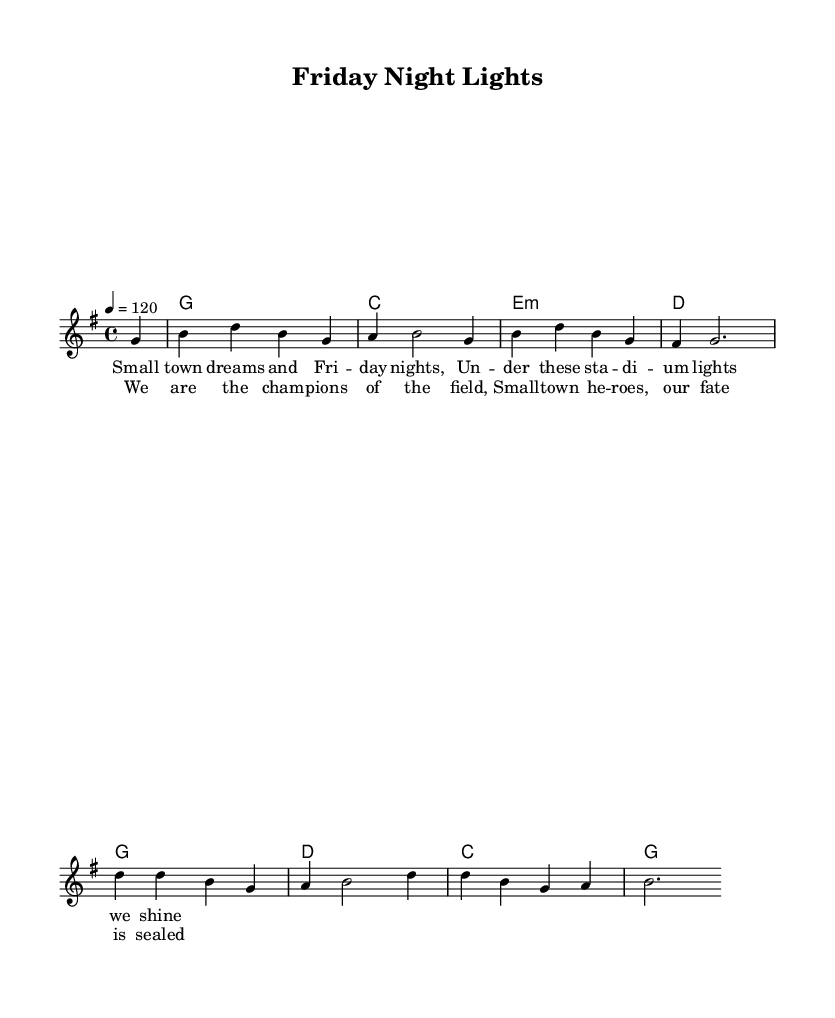What is the key signature of this music? The key signature is G major, which has one sharp (F#). This can be determined by looking at the key signature indicated at the beginning of the sheet music.
Answer: G major What is the time signature of this piece? The time signature is 4/4, which indicates that there are four beats in a measure and the quarter note gets one beat. This is shown at the start of the sheet music.
Answer: 4/4 What is the tempo marking in the score? The tempo marking is 120 beats per minute, which is indicated at the beginning of the score with the annotation "4 = 120".
Answer: 120 How many measures are in the melody? There are 8 measures in the melody section, which can be counted by observing the bar lines separating the musical segments in the melody.
Answer: 8 What is the theme of the lyrics in the verse? The theme of the lyrics in the verse revolves around small-town pride and high school football games, as indicated by lines like "Small town dreams and Friday nights." This reflects the overall narrative of celebrating local sports and community spirit.
Answer: Small-town pride In what section do we hear the chorus lyrics? The chorus lyrics are heard after the verse, indicating a repeated and emphasized section that celebrates the football team's achievements, as shown by their placement in the score after the verse lyrics.
Answer: Chorus What small-town scenario is celebrated in the lyrics? The lyrics celebrate Friday night football games, which is a traditional and significant event in many small towns across America, representing community and team spirit. This can be inferred from phrases like "Under these stadium lights we shine."
Answer: Friday night football 